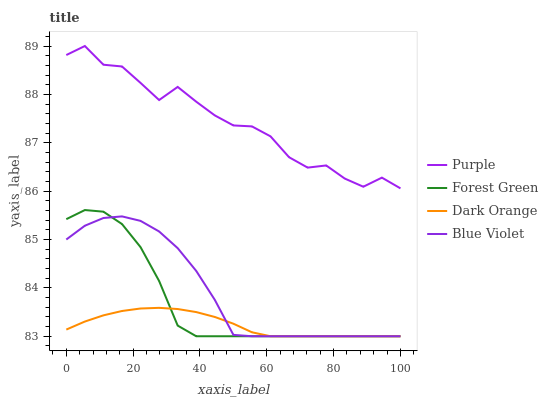Does Dark Orange have the minimum area under the curve?
Answer yes or no. Yes. Does Purple have the maximum area under the curve?
Answer yes or no. Yes. Does Forest Green have the minimum area under the curve?
Answer yes or no. No. Does Forest Green have the maximum area under the curve?
Answer yes or no. No. Is Dark Orange the smoothest?
Answer yes or no. Yes. Is Purple the roughest?
Answer yes or no. Yes. Is Forest Green the smoothest?
Answer yes or no. No. Is Forest Green the roughest?
Answer yes or no. No. Does Purple have the highest value?
Answer yes or no. Yes. Does Forest Green have the highest value?
Answer yes or no. No. Is Blue Violet less than Purple?
Answer yes or no. Yes. Is Purple greater than Blue Violet?
Answer yes or no. Yes. Does Dark Orange intersect Forest Green?
Answer yes or no. Yes. Is Dark Orange less than Forest Green?
Answer yes or no. No. Is Dark Orange greater than Forest Green?
Answer yes or no. No. Does Blue Violet intersect Purple?
Answer yes or no. No. 